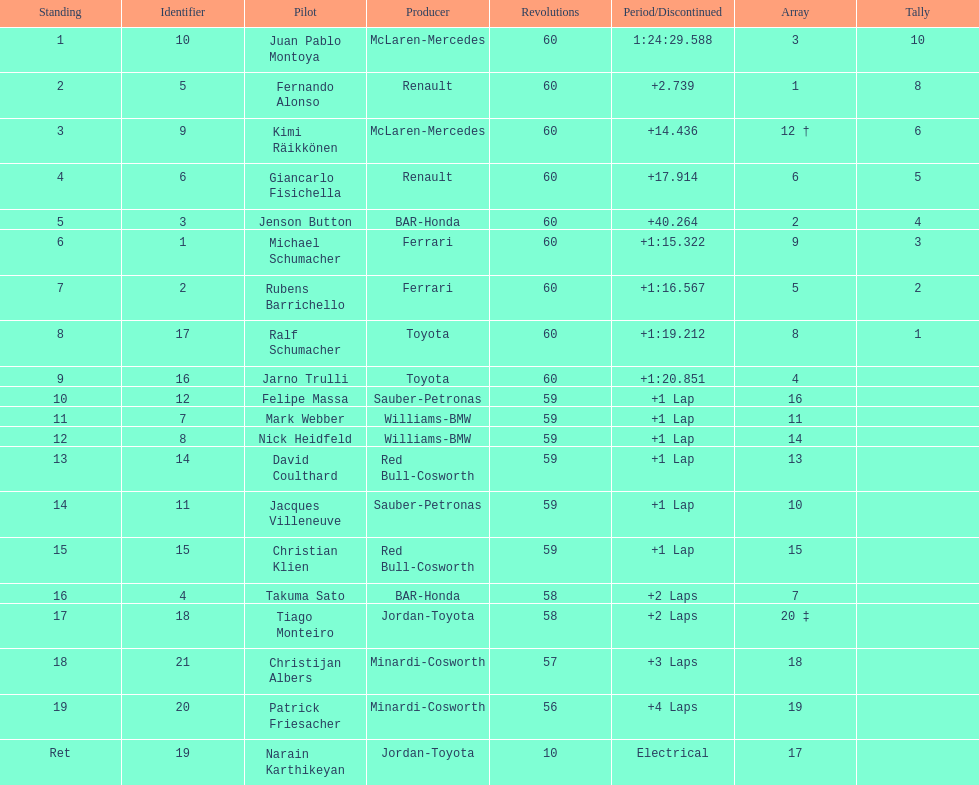How many drivers from germany? 3. Can you parse all the data within this table? {'header': ['Standing', 'Identifier', 'Pilot', 'Producer', 'Revolutions', 'Period/Discontinued', 'Array', 'Tally'], 'rows': [['1', '10', 'Juan Pablo Montoya', 'McLaren-Mercedes', '60', '1:24:29.588', '3', '10'], ['2', '5', 'Fernando Alonso', 'Renault', '60', '+2.739', '1', '8'], ['3', '9', 'Kimi Räikkönen', 'McLaren-Mercedes', '60', '+14.436', '12 †', '6'], ['4', '6', 'Giancarlo Fisichella', 'Renault', '60', '+17.914', '6', '5'], ['5', '3', 'Jenson Button', 'BAR-Honda', '60', '+40.264', '2', '4'], ['6', '1', 'Michael Schumacher', 'Ferrari', '60', '+1:15.322', '9', '3'], ['7', '2', 'Rubens Barrichello', 'Ferrari', '60', '+1:16.567', '5', '2'], ['8', '17', 'Ralf Schumacher', 'Toyota', '60', '+1:19.212', '8', '1'], ['9', '16', 'Jarno Trulli', 'Toyota', '60', '+1:20.851', '4', ''], ['10', '12', 'Felipe Massa', 'Sauber-Petronas', '59', '+1 Lap', '16', ''], ['11', '7', 'Mark Webber', 'Williams-BMW', '59', '+1 Lap', '11', ''], ['12', '8', 'Nick Heidfeld', 'Williams-BMW', '59', '+1 Lap', '14', ''], ['13', '14', 'David Coulthard', 'Red Bull-Cosworth', '59', '+1 Lap', '13', ''], ['14', '11', 'Jacques Villeneuve', 'Sauber-Petronas', '59', '+1 Lap', '10', ''], ['15', '15', 'Christian Klien', 'Red Bull-Cosworth', '59', '+1 Lap', '15', ''], ['16', '4', 'Takuma Sato', 'BAR-Honda', '58', '+2 Laps', '7', ''], ['17', '18', 'Tiago Monteiro', 'Jordan-Toyota', '58', '+2 Laps', '20 ‡', ''], ['18', '21', 'Christijan Albers', 'Minardi-Cosworth', '57', '+3 Laps', '18', ''], ['19', '20', 'Patrick Friesacher', 'Minardi-Cosworth', '56', '+4 Laps', '19', ''], ['Ret', '19', 'Narain Karthikeyan', 'Jordan-Toyota', '10', 'Electrical', '17', '']]} 